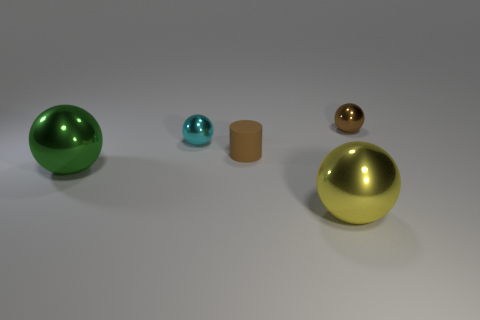Subtract 1 balls. How many balls are left? 3 Add 3 green metal spheres. How many objects exist? 8 Subtract all balls. How many objects are left? 1 Subtract 0 red balls. How many objects are left? 5 Subtract all small cyan metallic things. Subtract all brown metallic objects. How many objects are left? 3 Add 1 green objects. How many green objects are left? 2 Add 1 big matte cubes. How many big matte cubes exist? 1 